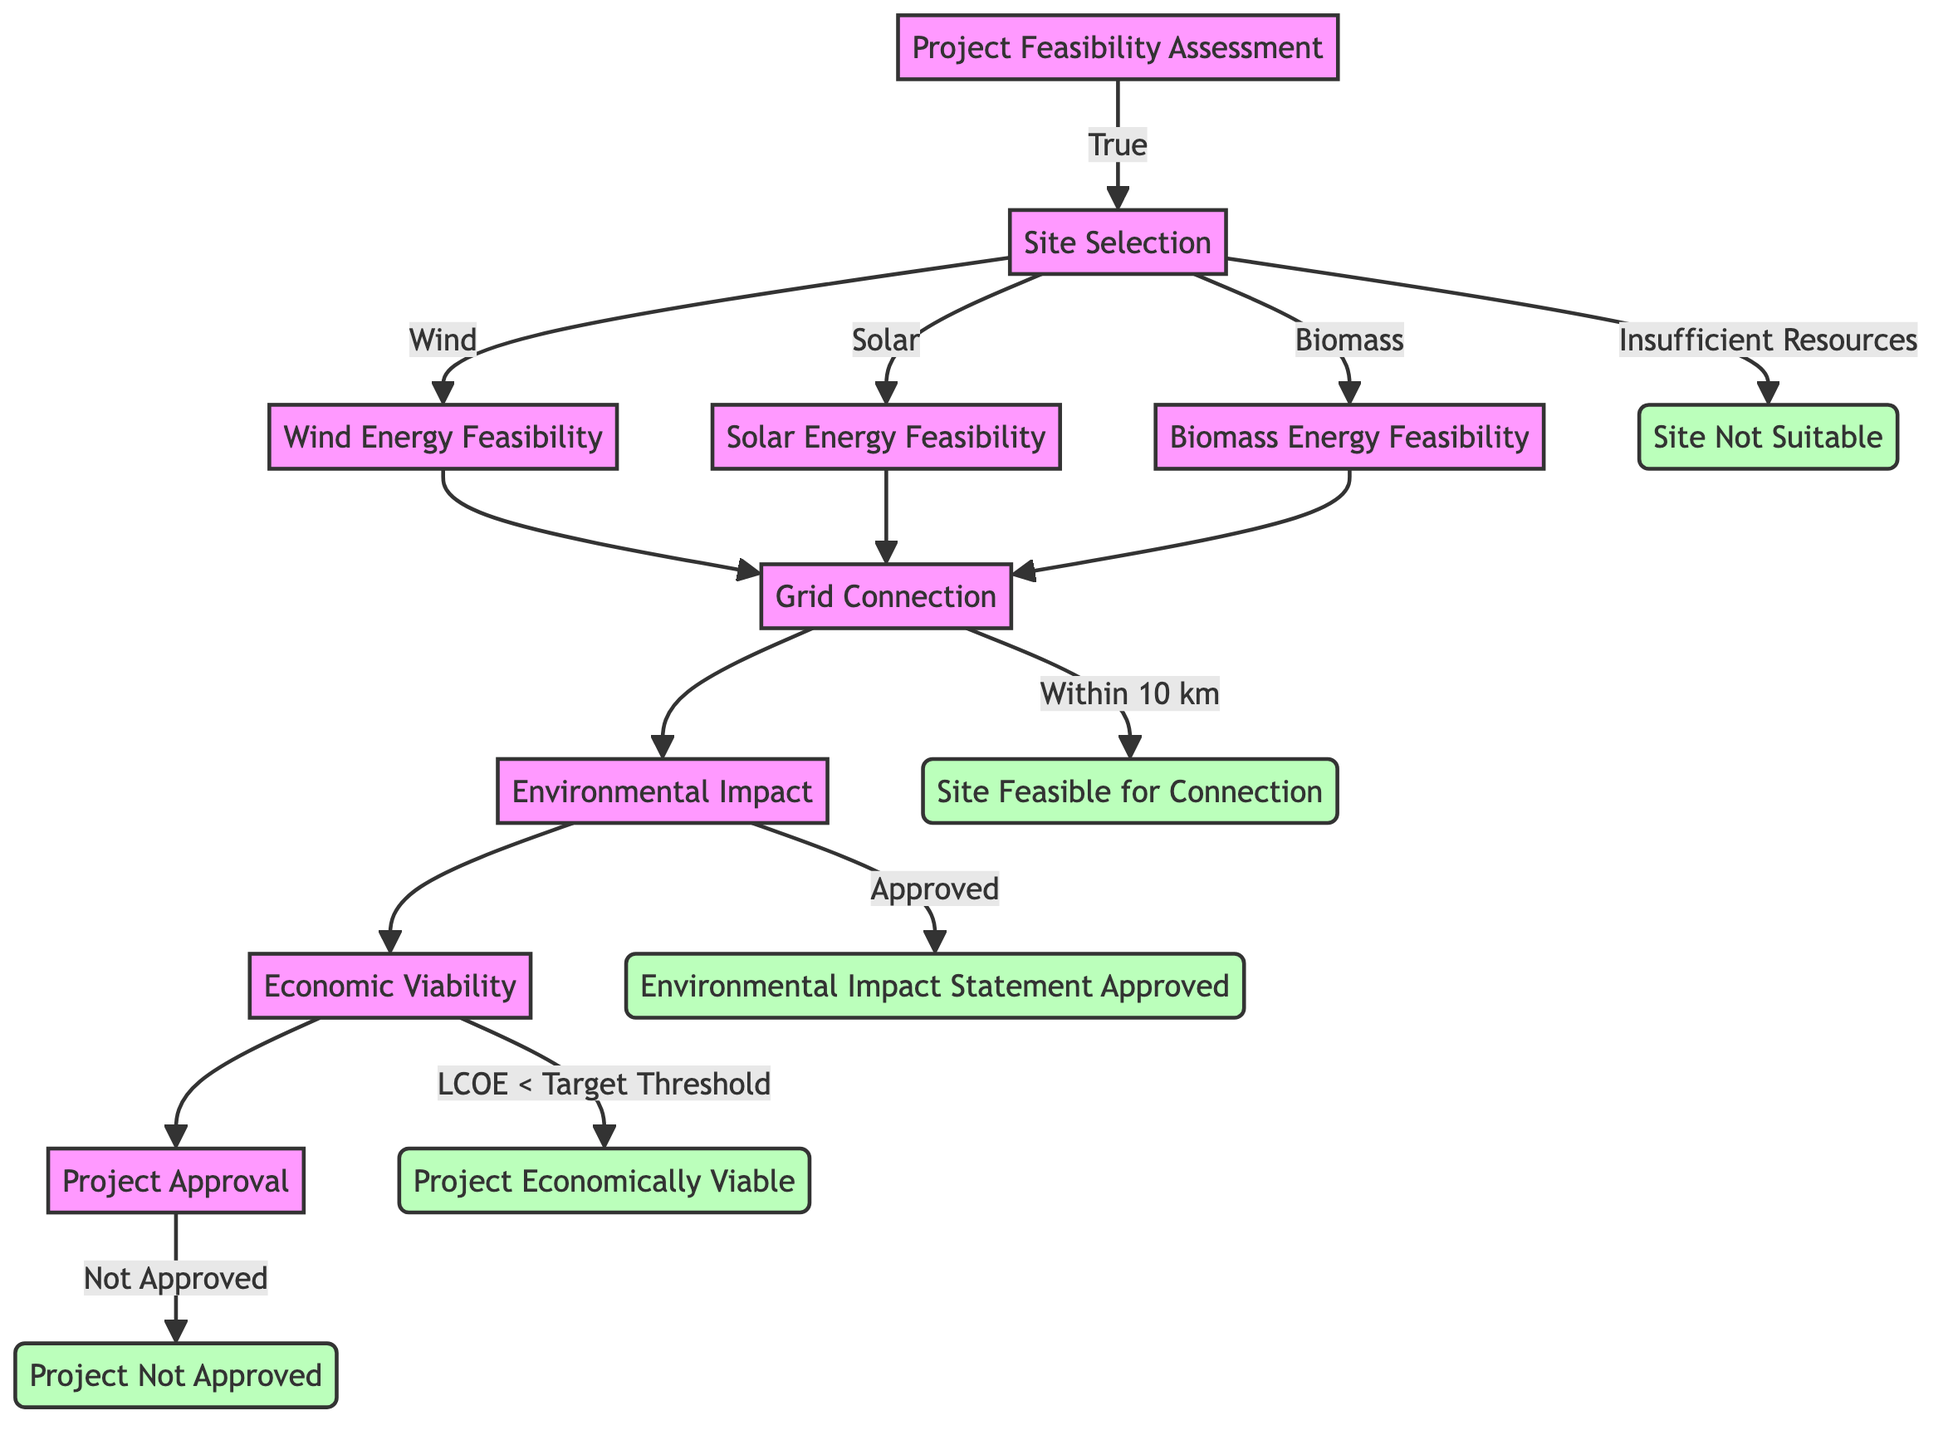What is the first question in the decision tree? The first node in the diagram asks if the project site is available for renewable energy deployment, and this is the initial decision point for feasibility assessment.
Answer: Is the project site available for renewable energy deployment? How many nodes are there in total? There are 14 nodes identified in the decision tree, which include both decision and outcome nodes.
Answer: 14 What determines resource type in the site selection step? The site selection step leads to three branches based on the resource type: Wind, Solar, or Biomass, which determines which feasibility assessment follows.
Answer: Wind, Solar, Biomass What is the outcome if the Levelized Cost of Energy is below the target threshold? If the LCOE meets the condition of being below the target threshold, the outcome is that the project is considered economically viable.
Answer: Project Economically Viable What must be true for the site to be deemed suitable for connection? The site must be located within 10 km of the nearest grid connection point for it to be feasible for connection, which is a key decision point in the diagram.
Answer: Within 10 km What happens if the environmental impact assessment is not approved? If the environmental impact assessment is not approved, the implication is that the project will not pass the environmental impact step, leading to potential rejection of the project.
Answer: Project Not Approved If the project site has insufficient resources, what will be the outcome? Should there be insufficient wind, solar, or biomass resources available at the site, the outcome is that the site is not suitable for the project.
Answer: Site Not Suitable Which decision node leads to the environmental impact assessment? The decision node pertaining to the grid connection leads to the environmental impact assessment; if the grid connection is confirmed, this step follows.
Answer: Grid Connection What is the final decision point in the diagram? The final decision point is regarding project approval, determining whether the project has been approved by relevant authorities.
Answer: Is the project approved by relevant authorities? 